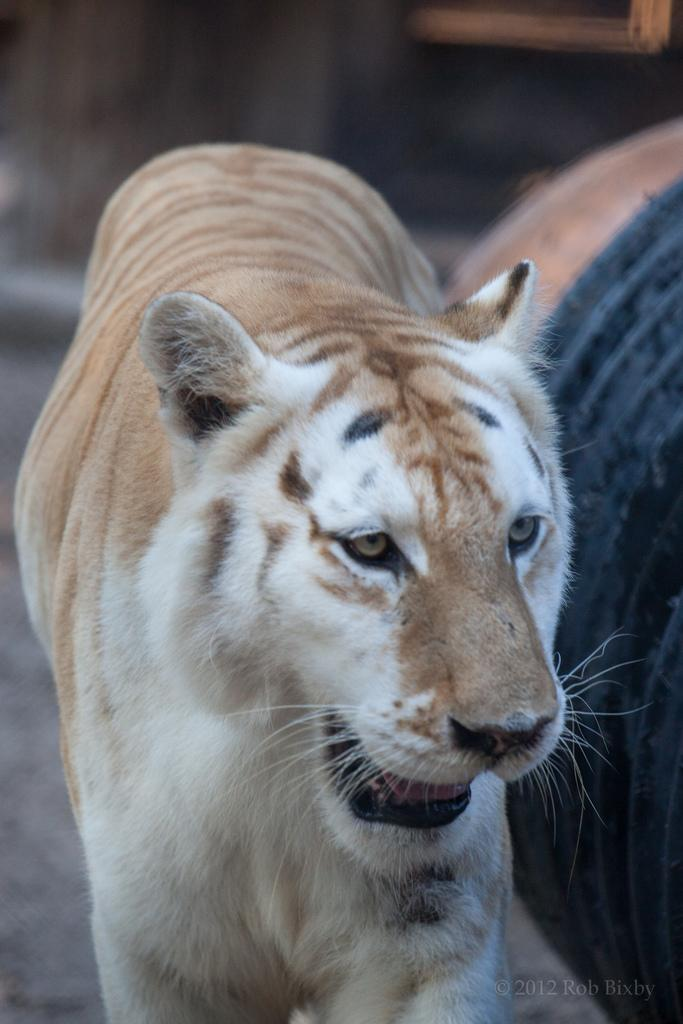What animal is the main subject of the image? There is a tiger in the image. Can you describe the color of the tiger? The tiger is white and brown in color. What is the tiger doing in the image? The tiger is standing. What else can be seen in the image besides the tiger? There is a black colored object in the image. How would you describe the background of the image? The background of the image is blurry. How does the beginner tiger learn to make fewer errors in the image? There is no indication in the image that the tiger is a beginner or making errors, as it is simply standing and not performing any specific task. 